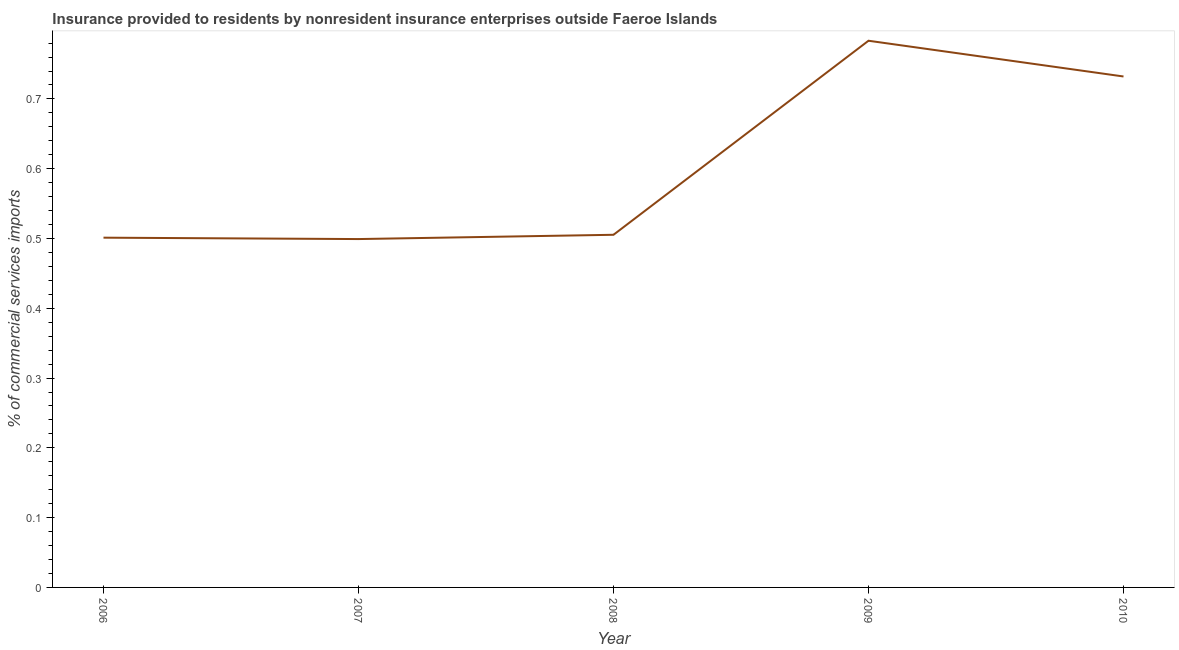What is the insurance provided by non-residents in 2010?
Ensure brevity in your answer.  0.73. Across all years, what is the maximum insurance provided by non-residents?
Make the answer very short. 0.78. Across all years, what is the minimum insurance provided by non-residents?
Offer a terse response. 0.5. In which year was the insurance provided by non-residents maximum?
Offer a terse response. 2009. In which year was the insurance provided by non-residents minimum?
Offer a terse response. 2007. What is the sum of the insurance provided by non-residents?
Keep it short and to the point. 3.02. What is the difference between the insurance provided by non-residents in 2007 and 2009?
Your answer should be compact. -0.28. What is the average insurance provided by non-residents per year?
Offer a terse response. 0.6. What is the median insurance provided by non-residents?
Your answer should be compact. 0.51. Do a majority of the years between 2009 and 2006 (inclusive) have insurance provided by non-residents greater than 0.5 %?
Your response must be concise. Yes. What is the ratio of the insurance provided by non-residents in 2008 to that in 2010?
Your answer should be compact. 0.69. What is the difference between the highest and the second highest insurance provided by non-residents?
Offer a very short reply. 0.05. What is the difference between the highest and the lowest insurance provided by non-residents?
Provide a short and direct response. 0.28. Does the insurance provided by non-residents monotonically increase over the years?
Provide a short and direct response. No. How many years are there in the graph?
Your answer should be compact. 5. What is the title of the graph?
Offer a terse response. Insurance provided to residents by nonresident insurance enterprises outside Faeroe Islands. What is the label or title of the X-axis?
Your answer should be very brief. Year. What is the label or title of the Y-axis?
Provide a short and direct response. % of commercial services imports. What is the % of commercial services imports of 2006?
Your answer should be very brief. 0.5. What is the % of commercial services imports of 2007?
Offer a very short reply. 0.5. What is the % of commercial services imports of 2008?
Your answer should be compact. 0.51. What is the % of commercial services imports in 2009?
Offer a very short reply. 0.78. What is the % of commercial services imports in 2010?
Ensure brevity in your answer.  0.73. What is the difference between the % of commercial services imports in 2006 and 2007?
Provide a succinct answer. 0. What is the difference between the % of commercial services imports in 2006 and 2008?
Offer a very short reply. -0. What is the difference between the % of commercial services imports in 2006 and 2009?
Provide a succinct answer. -0.28. What is the difference between the % of commercial services imports in 2006 and 2010?
Your response must be concise. -0.23. What is the difference between the % of commercial services imports in 2007 and 2008?
Ensure brevity in your answer.  -0.01. What is the difference between the % of commercial services imports in 2007 and 2009?
Ensure brevity in your answer.  -0.28. What is the difference between the % of commercial services imports in 2007 and 2010?
Give a very brief answer. -0.23. What is the difference between the % of commercial services imports in 2008 and 2009?
Ensure brevity in your answer.  -0.28. What is the difference between the % of commercial services imports in 2008 and 2010?
Offer a very short reply. -0.23. What is the difference between the % of commercial services imports in 2009 and 2010?
Ensure brevity in your answer.  0.05. What is the ratio of the % of commercial services imports in 2006 to that in 2008?
Keep it short and to the point. 0.99. What is the ratio of the % of commercial services imports in 2006 to that in 2009?
Make the answer very short. 0.64. What is the ratio of the % of commercial services imports in 2006 to that in 2010?
Give a very brief answer. 0.69. What is the ratio of the % of commercial services imports in 2007 to that in 2008?
Offer a terse response. 0.99. What is the ratio of the % of commercial services imports in 2007 to that in 2009?
Provide a succinct answer. 0.64. What is the ratio of the % of commercial services imports in 2007 to that in 2010?
Offer a terse response. 0.68. What is the ratio of the % of commercial services imports in 2008 to that in 2009?
Your answer should be compact. 0.65. What is the ratio of the % of commercial services imports in 2008 to that in 2010?
Keep it short and to the point. 0.69. What is the ratio of the % of commercial services imports in 2009 to that in 2010?
Your answer should be compact. 1.07. 